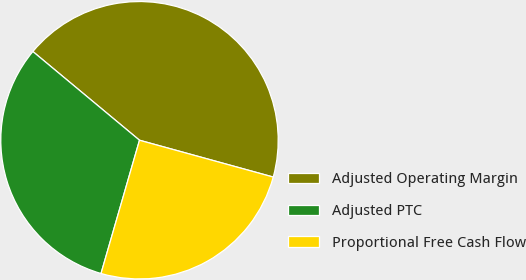Convert chart. <chart><loc_0><loc_0><loc_500><loc_500><pie_chart><fcel>Adjusted Operating Margin<fcel>Adjusted PTC<fcel>Proportional Free Cash Flow<nl><fcel>43.23%<fcel>31.57%<fcel>25.2%<nl></chart> 